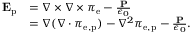<formula> <loc_0><loc_0><loc_500><loc_500>{ \begin{array} { r l } { E _ { p } } & { = \nabla \times \nabla \times { \pi } _ { e } - { \frac { P } { \epsilon _ { 0 } } } } \\ & { = \nabla ( \nabla \cdot { \pi } _ { e , p } ) - \nabla ^ { 2 } { \pi } _ { e , p } - { \frac { P } { \epsilon _ { 0 } } } . } \end{array} }</formula> 